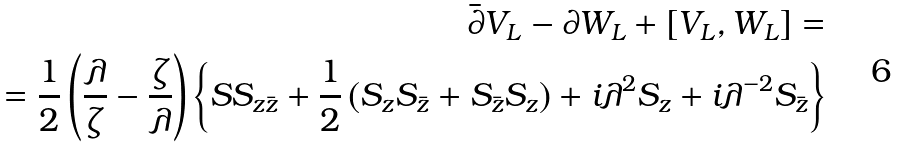<formula> <loc_0><loc_0><loc_500><loc_500>\bar { \partial } V _ { L } - \partial W _ { L } + \left [ V _ { L } , W _ { L } \right ] = \\ = \frac { 1 } { 2 } \left ( \frac { \lambda } { \zeta } - \frac { \zeta } { \lambda } \right ) \left \{ S S _ { z \bar { z } } + \frac { 1 } { 2 } \left ( S _ { z } S _ { \bar { z } } + S _ { \bar { z } } S _ { z } \right ) + i \lambda ^ { 2 } S _ { z } + i \lambda ^ { - 2 } S _ { \bar { z } } \right \}</formula> 